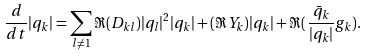Convert formula to latex. <formula><loc_0><loc_0><loc_500><loc_500>\frac { d } { d t } | q _ { k } | = \sum _ { l \not = 1 } \Re ( D _ { k l } ) | q _ { l } | ^ { 2 } | q _ { k } | + ( \Re Y _ { k } ) | q _ { k } | + \Re ( \frac { \bar { q } _ { k } } { | q _ { k } | } g _ { k } ) .</formula> 